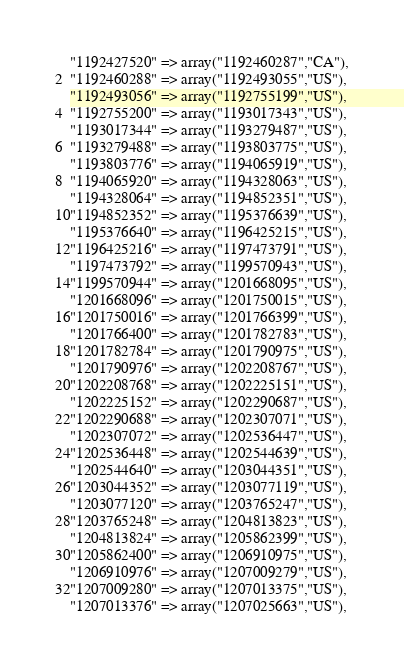Convert code to text. <code><loc_0><loc_0><loc_500><loc_500><_PHP_>"1192427520" => array("1192460287","CA"),
"1192460288" => array("1192493055","US"),
"1192493056" => array("1192755199","US"),
"1192755200" => array("1193017343","US"),
"1193017344" => array("1193279487","US"),
"1193279488" => array("1193803775","US"),
"1193803776" => array("1194065919","US"),
"1194065920" => array("1194328063","US"),
"1194328064" => array("1194852351","US"),
"1194852352" => array("1195376639","US"),
"1195376640" => array("1196425215","US"),
"1196425216" => array("1197473791","US"),
"1197473792" => array("1199570943","US"),
"1199570944" => array("1201668095","US"),
"1201668096" => array("1201750015","US"),
"1201750016" => array("1201766399","US"),
"1201766400" => array("1201782783","US"),
"1201782784" => array("1201790975","US"),
"1201790976" => array("1202208767","US"),
"1202208768" => array("1202225151","US"),
"1202225152" => array("1202290687","US"),
"1202290688" => array("1202307071","US"),
"1202307072" => array("1202536447","US"),
"1202536448" => array("1202544639","US"),
"1202544640" => array("1203044351","US"),
"1203044352" => array("1203077119","US"),
"1203077120" => array("1203765247","US"),
"1203765248" => array("1204813823","US"),
"1204813824" => array("1205862399","US"),
"1205862400" => array("1206910975","US"),
"1206910976" => array("1207009279","US"),
"1207009280" => array("1207013375","US"),
"1207013376" => array("1207025663","US"),</code> 